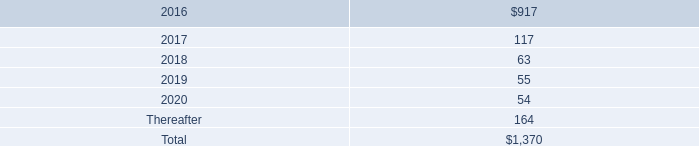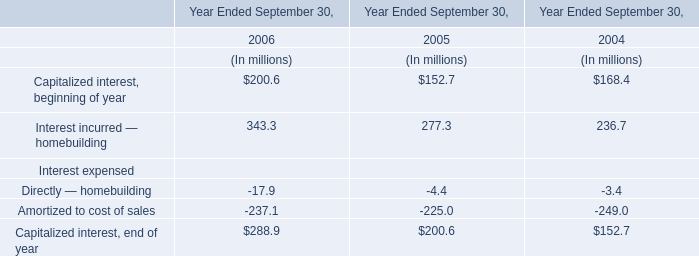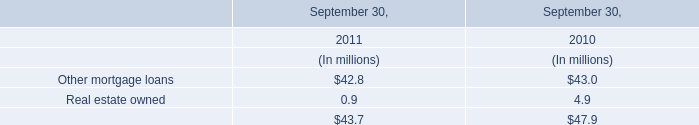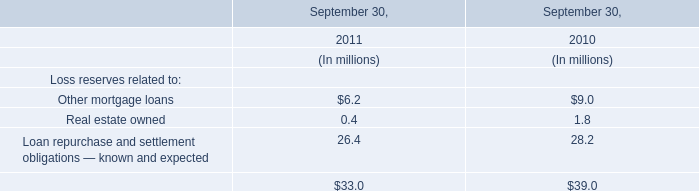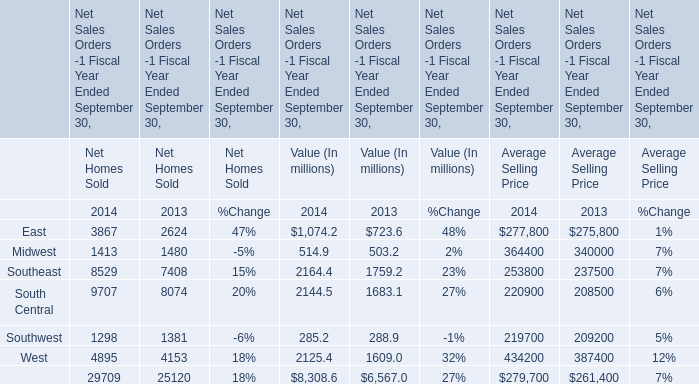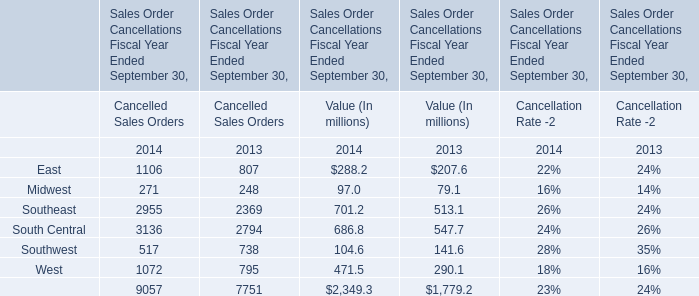What's the 20 % of total elements for Value (In millions) in 2013? (in million) 
Computations: (1779.2 * 0.2)
Answer: 355.84. 